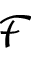Convert formula to latex. <formula><loc_0><loc_0><loc_500><loc_500>\mathcal { F }</formula> 